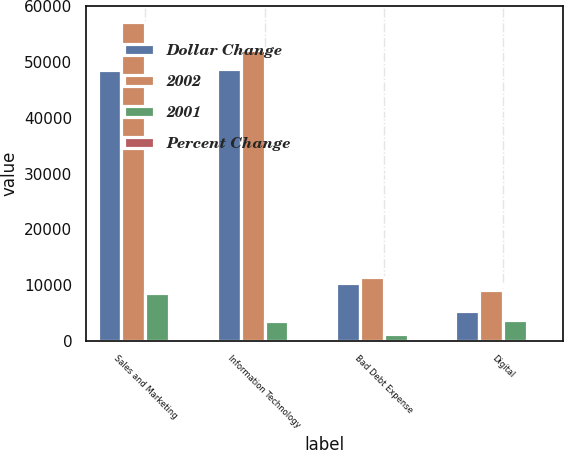<chart> <loc_0><loc_0><loc_500><loc_500><stacked_bar_chart><ecel><fcel>Sales and Marketing<fcel>Information Technology<fcel>Bad Debt Expense<fcel>Digital<nl><fcel>Dollar Change<fcel>48580<fcel>48663<fcel>10334<fcel>5391<nl><fcel>2002<fcel>57198<fcel>52236<fcel>11533<fcel>9074<nl><fcel>2001<fcel>8618<fcel>3573<fcel>1199<fcel>3683<nl><fcel>Percent Change<fcel>17.7<fcel>7.3<fcel>11.6<fcel>68.3<nl></chart> 